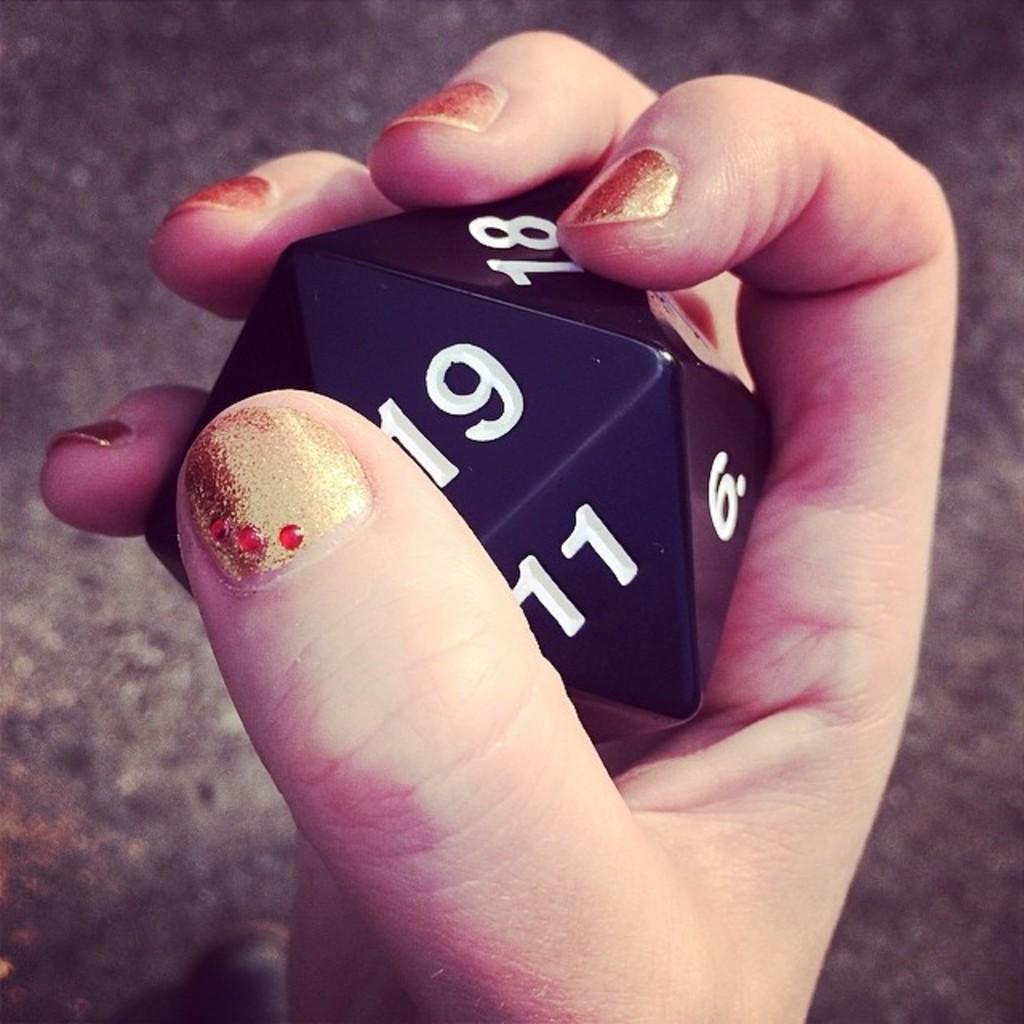Describe this image in one or two sentences. In this image I can see a person's hand holding a dice having few numbers on it. Background there is a floor. 